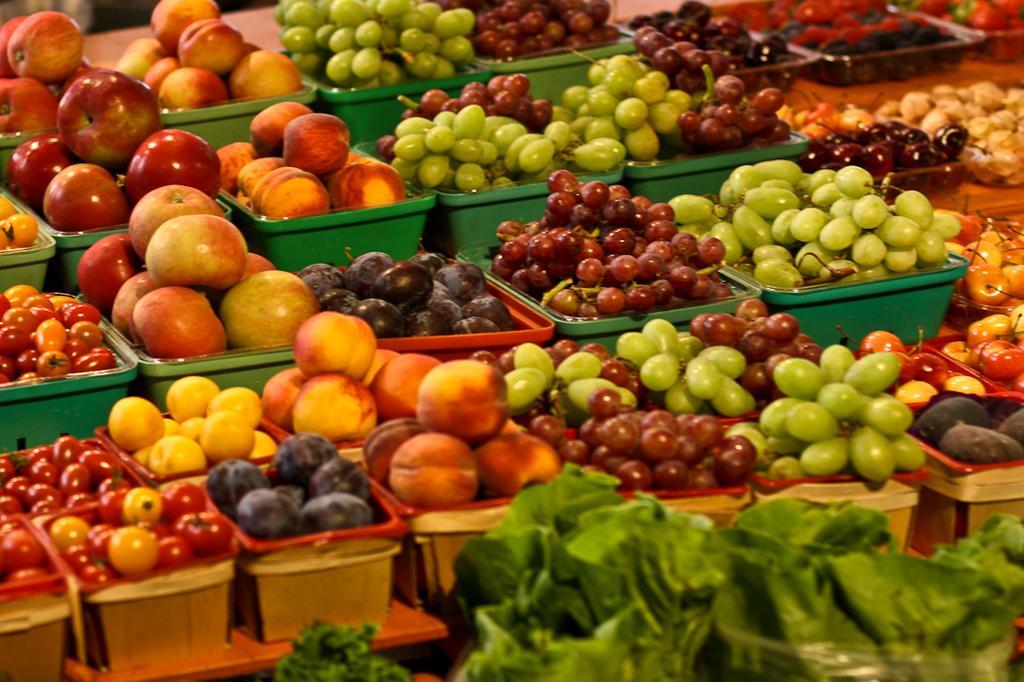Can you describe this image briefly? There are apples, grapes and other fruits arranged in the baskets, which are in different colors. In front of them, there are leaves arranged. 